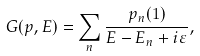Convert formula to latex. <formula><loc_0><loc_0><loc_500><loc_500>G ( p , E ) = \sum _ { n } \frac { p _ { n } ( 1 ) } { E - E _ { n } + i \varepsilon } ,</formula> 